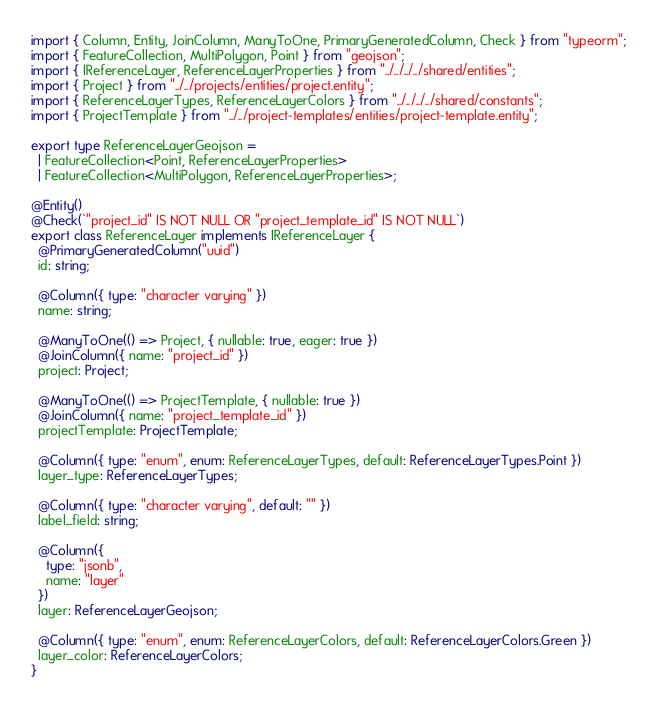<code> <loc_0><loc_0><loc_500><loc_500><_TypeScript_>import { Column, Entity, JoinColumn, ManyToOne, PrimaryGeneratedColumn, Check } from "typeorm";
import { FeatureCollection, MultiPolygon, Point } from "geojson";
import { IReferenceLayer, ReferenceLayerProperties } from "../../../../shared/entities";
import { Project } from "../../projects/entities/project.entity";
import { ReferenceLayerTypes, ReferenceLayerColors } from "../../../../shared/constants";
import { ProjectTemplate } from "../../project-templates/entities/project-template.entity";

export type ReferenceLayerGeojson =
  | FeatureCollection<Point, ReferenceLayerProperties>
  | FeatureCollection<MultiPolygon, ReferenceLayerProperties>;

@Entity()
@Check(`"project_id" IS NOT NULL OR "project_template_id" IS NOT NULL`)
export class ReferenceLayer implements IReferenceLayer {
  @PrimaryGeneratedColumn("uuid")
  id: string;

  @Column({ type: "character varying" })
  name: string;

  @ManyToOne(() => Project, { nullable: true, eager: true })
  @JoinColumn({ name: "project_id" })
  project: Project;

  @ManyToOne(() => ProjectTemplate, { nullable: true })
  @JoinColumn({ name: "project_template_id" })
  projectTemplate: ProjectTemplate;

  @Column({ type: "enum", enum: ReferenceLayerTypes, default: ReferenceLayerTypes.Point })
  layer_type: ReferenceLayerTypes;

  @Column({ type: "character varying", default: "" })
  label_field: string;

  @Column({
    type: "jsonb",
    name: "layer"
  })
  layer: ReferenceLayerGeojson;

  @Column({ type: "enum", enum: ReferenceLayerColors, default: ReferenceLayerColors.Green })
  layer_color: ReferenceLayerColors;
}
</code> 